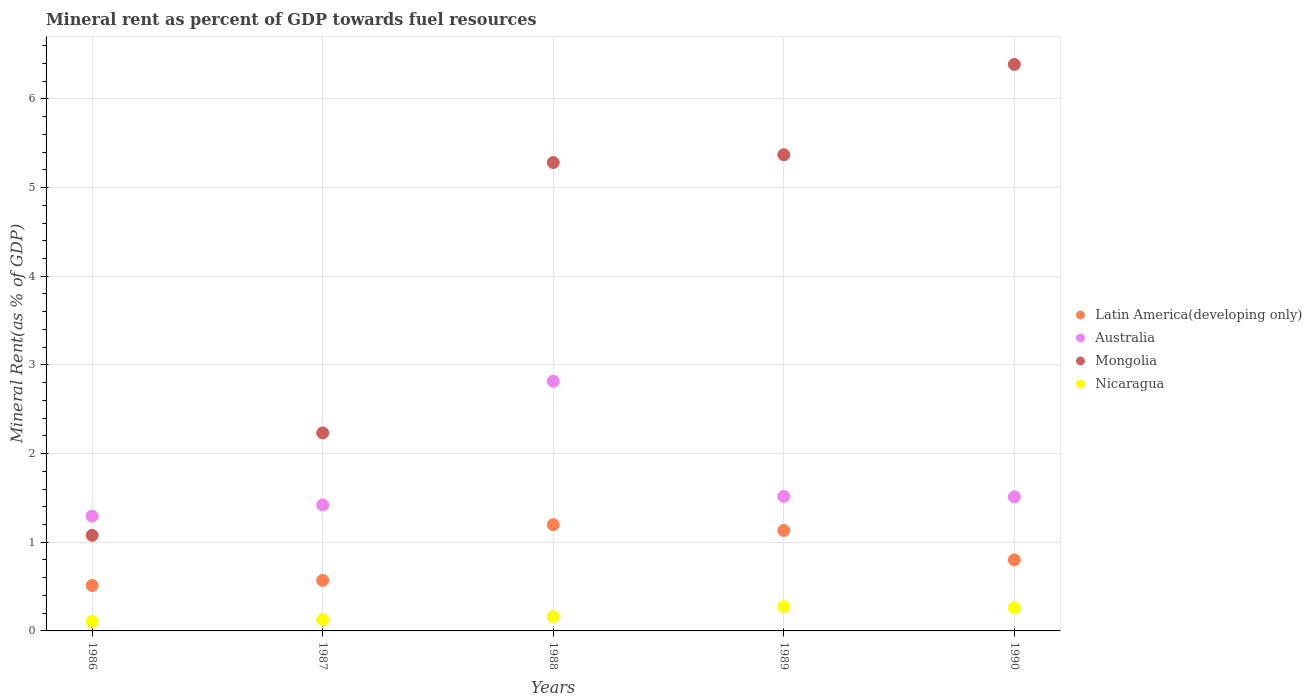What is the mineral rent in Mongolia in 1987?
Your response must be concise. 2.23. Across all years, what is the maximum mineral rent in Nicaragua?
Make the answer very short. 0.27. Across all years, what is the minimum mineral rent in Mongolia?
Keep it short and to the point. 1.08. In which year was the mineral rent in Nicaragua minimum?
Ensure brevity in your answer.  1986. What is the total mineral rent in Mongolia in the graph?
Your answer should be compact. 20.35. What is the difference between the mineral rent in Latin America(developing only) in 1986 and that in 1987?
Keep it short and to the point. -0.06. What is the difference between the mineral rent in Latin America(developing only) in 1990 and the mineral rent in Mongolia in 1987?
Offer a very short reply. -1.43. What is the average mineral rent in Nicaragua per year?
Keep it short and to the point. 0.19. In the year 1988, what is the difference between the mineral rent in Latin America(developing only) and mineral rent in Mongolia?
Offer a terse response. -4.08. What is the ratio of the mineral rent in Nicaragua in 1986 to that in 1987?
Provide a succinct answer. 0.83. Is the difference between the mineral rent in Latin America(developing only) in 1989 and 1990 greater than the difference between the mineral rent in Mongolia in 1989 and 1990?
Offer a very short reply. Yes. What is the difference between the highest and the second highest mineral rent in Mongolia?
Offer a very short reply. 1.02. What is the difference between the highest and the lowest mineral rent in Nicaragua?
Your response must be concise. 0.17. Does the mineral rent in Latin America(developing only) monotonically increase over the years?
Provide a short and direct response. No. How many dotlines are there?
Ensure brevity in your answer.  4. How many years are there in the graph?
Your response must be concise. 5. What is the difference between two consecutive major ticks on the Y-axis?
Your answer should be compact. 1. Does the graph contain grids?
Ensure brevity in your answer.  Yes. Where does the legend appear in the graph?
Ensure brevity in your answer.  Center right. What is the title of the graph?
Your response must be concise. Mineral rent as percent of GDP towards fuel resources. Does "Luxembourg" appear as one of the legend labels in the graph?
Your response must be concise. No. What is the label or title of the X-axis?
Your response must be concise. Years. What is the label or title of the Y-axis?
Your response must be concise. Mineral Rent(as % of GDP). What is the Mineral Rent(as % of GDP) of Latin America(developing only) in 1986?
Offer a very short reply. 0.51. What is the Mineral Rent(as % of GDP) in Australia in 1986?
Provide a succinct answer. 1.29. What is the Mineral Rent(as % of GDP) in Mongolia in 1986?
Your response must be concise. 1.08. What is the Mineral Rent(as % of GDP) of Nicaragua in 1986?
Your answer should be compact. 0.11. What is the Mineral Rent(as % of GDP) in Latin America(developing only) in 1987?
Make the answer very short. 0.57. What is the Mineral Rent(as % of GDP) of Australia in 1987?
Offer a very short reply. 1.42. What is the Mineral Rent(as % of GDP) of Mongolia in 1987?
Keep it short and to the point. 2.23. What is the Mineral Rent(as % of GDP) in Nicaragua in 1987?
Offer a very short reply. 0.13. What is the Mineral Rent(as % of GDP) of Latin America(developing only) in 1988?
Give a very brief answer. 1.2. What is the Mineral Rent(as % of GDP) of Australia in 1988?
Your answer should be very brief. 2.82. What is the Mineral Rent(as % of GDP) in Mongolia in 1988?
Provide a short and direct response. 5.28. What is the Mineral Rent(as % of GDP) of Nicaragua in 1988?
Give a very brief answer. 0.16. What is the Mineral Rent(as % of GDP) in Latin America(developing only) in 1989?
Provide a short and direct response. 1.13. What is the Mineral Rent(as % of GDP) of Australia in 1989?
Keep it short and to the point. 1.52. What is the Mineral Rent(as % of GDP) of Mongolia in 1989?
Your answer should be very brief. 5.37. What is the Mineral Rent(as % of GDP) of Nicaragua in 1989?
Ensure brevity in your answer.  0.27. What is the Mineral Rent(as % of GDP) in Latin America(developing only) in 1990?
Keep it short and to the point. 0.8. What is the Mineral Rent(as % of GDP) of Australia in 1990?
Offer a very short reply. 1.51. What is the Mineral Rent(as % of GDP) in Mongolia in 1990?
Offer a terse response. 6.39. What is the Mineral Rent(as % of GDP) of Nicaragua in 1990?
Offer a very short reply. 0.26. Across all years, what is the maximum Mineral Rent(as % of GDP) in Latin America(developing only)?
Your response must be concise. 1.2. Across all years, what is the maximum Mineral Rent(as % of GDP) in Australia?
Provide a short and direct response. 2.82. Across all years, what is the maximum Mineral Rent(as % of GDP) of Mongolia?
Your answer should be compact. 6.39. Across all years, what is the maximum Mineral Rent(as % of GDP) of Nicaragua?
Your response must be concise. 0.27. Across all years, what is the minimum Mineral Rent(as % of GDP) in Latin America(developing only)?
Your answer should be very brief. 0.51. Across all years, what is the minimum Mineral Rent(as % of GDP) in Australia?
Your response must be concise. 1.29. Across all years, what is the minimum Mineral Rent(as % of GDP) in Mongolia?
Make the answer very short. 1.08. Across all years, what is the minimum Mineral Rent(as % of GDP) of Nicaragua?
Give a very brief answer. 0.11. What is the total Mineral Rent(as % of GDP) of Latin America(developing only) in the graph?
Give a very brief answer. 4.21. What is the total Mineral Rent(as % of GDP) in Australia in the graph?
Offer a terse response. 8.56. What is the total Mineral Rent(as % of GDP) of Mongolia in the graph?
Your response must be concise. 20.35. What is the total Mineral Rent(as % of GDP) in Nicaragua in the graph?
Offer a terse response. 0.93. What is the difference between the Mineral Rent(as % of GDP) of Latin America(developing only) in 1986 and that in 1987?
Give a very brief answer. -0.06. What is the difference between the Mineral Rent(as % of GDP) of Australia in 1986 and that in 1987?
Your answer should be compact. -0.13. What is the difference between the Mineral Rent(as % of GDP) of Mongolia in 1986 and that in 1987?
Offer a terse response. -1.16. What is the difference between the Mineral Rent(as % of GDP) of Nicaragua in 1986 and that in 1987?
Give a very brief answer. -0.02. What is the difference between the Mineral Rent(as % of GDP) of Latin America(developing only) in 1986 and that in 1988?
Keep it short and to the point. -0.69. What is the difference between the Mineral Rent(as % of GDP) of Australia in 1986 and that in 1988?
Your answer should be compact. -1.52. What is the difference between the Mineral Rent(as % of GDP) of Mongolia in 1986 and that in 1988?
Offer a very short reply. -4.2. What is the difference between the Mineral Rent(as % of GDP) in Nicaragua in 1986 and that in 1988?
Make the answer very short. -0.06. What is the difference between the Mineral Rent(as % of GDP) in Latin America(developing only) in 1986 and that in 1989?
Your response must be concise. -0.62. What is the difference between the Mineral Rent(as % of GDP) of Australia in 1986 and that in 1989?
Your answer should be very brief. -0.22. What is the difference between the Mineral Rent(as % of GDP) in Mongolia in 1986 and that in 1989?
Ensure brevity in your answer.  -4.29. What is the difference between the Mineral Rent(as % of GDP) in Nicaragua in 1986 and that in 1989?
Give a very brief answer. -0.17. What is the difference between the Mineral Rent(as % of GDP) of Latin America(developing only) in 1986 and that in 1990?
Offer a very short reply. -0.29. What is the difference between the Mineral Rent(as % of GDP) in Australia in 1986 and that in 1990?
Make the answer very short. -0.22. What is the difference between the Mineral Rent(as % of GDP) of Mongolia in 1986 and that in 1990?
Your answer should be compact. -5.31. What is the difference between the Mineral Rent(as % of GDP) of Nicaragua in 1986 and that in 1990?
Your answer should be very brief. -0.16. What is the difference between the Mineral Rent(as % of GDP) of Latin America(developing only) in 1987 and that in 1988?
Provide a short and direct response. -0.63. What is the difference between the Mineral Rent(as % of GDP) in Australia in 1987 and that in 1988?
Provide a short and direct response. -1.4. What is the difference between the Mineral Rent(as % of GDP) of Mongolia in 1987 and that in 1988?
Make the answer very short. -3.05. What is the difference between the Mineral Rent(as % of GDP) of Nicaragua in 1987 and that in 1988?
Your answer should be very brief. -0.03. What is the difference between the Mineral Rent(as % of GDP) of Latin America(developing only) in 1987 and that in 1989?
Your response must be concise. -0.56. What is the difference between the Mineral Rent(as % of GDP) in Australia in 1987 and that in 1989?
Give a very brief answer. -0.1. What is the difference between the Mineral Rent(as % of GDP) of Mongolia in 1987 and that in 1989?
Offer a terse response. -3.14. What is the difference between the Mineral Rent(as % of GDP) of Nicaragua in 1987 and that in 1989?
Offer a very short reply. -0.15. What is the difference between the Mineral Rent(as % of GDP) of Latin America(developing only) in 1987 and that in 1990?
Offer a very short reply. -0.23. What is the difference between the Mineral Rent(as % of GDP) in Australia in 1987 and that in 1990?
Provide a short and direct response. -0.09. What is the difference between the Mineral Rent(as % of GDP) in Mongolia in 1987 and that in 1990?
Ensure brevity in your answer.  -4.16. What is the difference between the Mineral Rent(as % of GDP) of Nicaragua in 1987 and that in 1990?
Your response must be concise. -0.14. What is the difference between the Mineral Rent(as % of GDP) in Latin America(developing only) in 1988 and that in 1989?
Your answer should be compact. 0.07. What is the difference between the Mineral Rent(as % of GDP) in Australia in 1988 and that in 1989?
Offer a terse response. 1.3. What is the difference between the Mineral Rent(as % of GDP) of Mongolia in 1988 and that in 1989?
Offer a terse response. -0.09. What is the difference between the Mineral Rent(as % of GDP) of Nicaragua in 1988 and that in 1989?
Offer a very short reply. -0.11. What is the difference between the Mineral Rent(as % of GDP) in Latin America(developing only) in 1988 and that in 1990?
Your answer should be compact. 0.4. What is the difference between the Mineral Rent(as % of GDP) of Australia in 1988 and that in 1990?
Ensure brevity in your answer.  1.3. What is the difference between the Mineral Rent(as % of GDP) of Mongolia in 1988 and that in 1990?
Offer a terse response. -1.11. What is the difference between the Mineral Rent(as % of GDP) of Nicaragua in 1988 and that in 1990?
Your answer should be very brief. -0.1. What is the difference between the Mineral Rent(as % of GDP) of Latin America(developing only) in 1989 and that in 1990?
Offer a terse response. 0.33. What is the difference between the Mineral Rent(as % of GDP) of Australia in 1989 and that in 1990?
Your answer should be compact. 0. What is the difference between the Mineral Rent(as % of GDP) in Mongolia in 1989 and that in 1990?
Your response must be concise. -1.02. What is the difference between the Mineral Rent(as % of GDP) of Nicaragua in 1989 and that in 1990?
Your response must be concise. 0.01. What is the difference between the Mineral Rent(as % of GDP) of Latin America(developing only) in 1986 and the Mineral Rent(as % of GDP) of Australia in 1987?
Offer a terse response. -0.91. What is the difference between the Mineral Rent(as % of GDP) in Latin America(developing only) in 1986 and the Mineral Rent(as % of GDP) in Mongolia in 1987?
Give a very brief answer. -1.72. What is the difference between the Mineral Rent(as % of GDP) of Latin America(developing only) in 1986 and the Mineral Rent(as % of GDP) of Nicaragua in 1987?
Provide a short and direct response. 0.39. What is the difference between the Mineral Rent(as % of GDP) of Australia in 1986 and the Mineral Rent(as % of GDP) of Mongolia in 1987?
Your answer should be very brief. -0.94. What is the difference between the Mineral Rent(as % of GDP) of Australia in 1986 and the Mineral Rent(as % of GDP) of Nicaragua in 1987?
Ensure brevity in your answer.  1.17. What is the difference between the Mineral Rent(as % of GDP) of Mongolia in 1986 and the Mineral Rent(as % of GDP) of Nicaragua in 1987?
Keep it short and to the point. 0.95. What is the difference between the Mineral Rent(as % of GDP) in Latin America(developing only) in 1986 and the Mineral Rent(as % of GDP) in Australia in 1988?
Offer a very short reply. -2.3. What is the difference between the Mineral Rent(as % of GDP) of Latin America(developing only) in 1986 and the Mineral Rent(as % of GDP) of Mongolia in 1988?
Your answer should be compact. -4.77. What is the difference between the Mineral Rent(as % of GDP) in Latin America(developing only) in 1986 and the Mineral Rent(as % of GDP) in Nicaragua in 1988?
Provide a succinct answer. 0.35. What is the difference between the Mineral Rent(as % of GDP) of Australia in 1986 and the Mineral Rent(as % of GDP) of Mongolia in 1988?
Keep it short and to the point. -3.99. What is the difference between the Mineral Rent(as % of GDP) in Australia in 1986 and the Mineral Rent(as % of GDP) in Nicaragua in 1988?
Give a very brief answer. 1.13. What is the difference between the Mineral Rent(as % of GDP) in Mongolia in 1986 and the Mineral Rent(as % of GDP) in Nicaragua in 1988?
Keep it short and to the point. 0.92. What is the difference between the Mineral Rent(as % of GDP) in Latin America(developing only) in 1986 and the Mineral Rent(as % of GDP) in Australia in 1989?
Keep it short and to the point. -1. What is the difference between the Mineral Rent(as % of GDP) of Latin America(developing only) in 1986 and the Mineral Rent(as % of GDP) of Mongolia in 1989?
Provide a short and direct response. -4.86. What is the difference between the Mineral Rent(as % of GDP) in Latin America(developing only) in 1986 and the Mineral Rent(as % of GDP) in Nicaragua in 1989?
Keep it short and to the point. 0.24. What is the difference between the Mineral Rent(as % of GDP) of Australia in 1986 and the Mineral Rent(as % of GDP) of Mongolia in 1989?
Your response must be concise. -4.08. What is the difference between the Mineral Rent(as % of GDP) of Australia in 1986 and the Mineral Rent(as % of GDP) of Nicaragua in 1989?
Your answer should be compact. 1.02. What is the difference between the Mineral Rent(as % of GDP) of Mongolia in 1986 and the Mineral Rent(as % of GDP) of Nicaragua in 1989?
Give a very brief answer. 0.81. What is the difference between the Mineral Rent(as % of GDP) of Latin America(developing only) in 1986 and the Mineral Rent(as % of GDP) of Australia in 1990?
Provide a short and direct response. -1. What is the difference between the Mineral Rent(as % of GDP) in Latin America(developing only) in 1986 and the Mineral Rent(as % of GDP) in Mongolia in 1990?
Your answer should be very brief. -5.88. What is the difference between the Mineral Rent(as % of GDP) in Latin America(developing only) in 1986 and the Mineral Rent(as % of GDP) in Nicaragua in 1990?
Keep it short and to the point. 0.25. What is the difference between the Mineral Rent(as % of GDP) of Australia in 1986 and the Mineral Rent(as % of GDP) of Mongolia in 1990?
Your answer should be compact. -5.09. What is the difference between the Mineral Rent(as % of GDP) in Australia in 1986 and the Mineral Rent(as % of GDP) in Nicaragua in 1990?
Provide a succinct answer. 1.03. What is the difference between the Mineral Rent(as % of GDP) of Mongolia in 1986 and the Mineral Rent(as % of GDP) of Nicaragua in 1990?
Provide a short and direct response. 0.82. What is the difference between the Mineral Rent(as % of GDP) of Latin America(developing only) in 1987 and the Mineral Rent(as % of GDP) of Australia in 1988?
Give a very brief answer. -2.25. What is the difference between the Mineral Rent(as % of GDP) in Latin America(developing only) in 1987 and the Mineral Rent(as % of GDP) in Mongolia in 1988?
Offer a very short reply. -4.71. What is the difference between the Mineral Rent(as % of GDP) of Latin America(developing only) in 1987 and the Mineral Rent(as % of GDP) of Nicaragua in 1988?
Offer a terse response. 0.41. What is the difference between the Mineral Rent(as % of GDP) of Australia in 1987 and the Mineral Rent(as % of GDP) of Mongolia in 1988?
Keep it short and to the point. -3.86. What is the difference between the Mineral Rent(as % of GDP) in Australia in 1987 and the Mineral Rent(as % of GDP) in Nicaragua in 1988?
Offer a terse response. 1.26. What is the difference between the Mineral Rent(as % of GDP) of Mongolia in 1987 and the Mineral Rent(as % of GDP) of Nicaragua in 1988?
Your response must be concise. 2.07. What is the difference between the Mineral Rent(as % of GDP) in Latin America(developing only) in 1987 and the Mineral Rent(as % of GDP) in Australia in 1989?
Ensure brevity in your answer.  -0.95. What is the difference between the Mineral Rent(as % of GDP) of Latin America(developing only) in 1987 and the Mineral Rent(as % of GDP) of Mongolia in 1989?
Provide a succinct answer. -4.8. What is the difference between the Mineral Rent(as % of GDP) in Latin America(developing only) in 1987 and the Mineral Rent(as % of GDP) in Nicaragua in 1989?
Your response must be concise. 0.3. What is the difference between the Mineral Rent(as % of GDP) in Australia in 1987 and the Mineral Rent(as % of GDP) in Mongolia in 1989?
Your answer should be very brief. -3.95. What is the difference between the Mineral Rent(as % of GDP) of Australia in 1987 and the Mineral Rent(as % of GDP) of Nicaragua in 1989?
Your answer should be very brief. 1.15. What is the difference between the Mineral Rent(as % of GDP) of Mongolia in 1987 and the Mineral Rent(as % of GDP) of Nicaragua in 1989?
Give a very brief answer. 1.96. What is the difference between the Mineral Rent(as % of GDP) in Latin America(developing only) in 1987 and the Mineral Rent(as % of GDP) in Australia in 1990?
Keep it short and to the point. -0.94. What is the difference between the Mineral Rent(as % of GDP) in Latin America(developing only) in 1987 and the Mineral Rent(as % of GDP) in Mongolia in 1990?
Make the answer very short. -5.82. What is the difference between the Mineral Rent(as % of GDP) of Latin America(developing only) in 1987 and the Mineral Rent(as % of GDP) of Nicaragua in 1990?
Keep it short and to the point. 0.31. What is the difference between the Mineral Rent(as % of GDP) of Australia in 1987 and the Mineral Rent(as % of GDP) of Mongolia in 1990?
Your answer should be very brief. -4.97. What is the difference between the Mineral Rent(as % of GDP) in Australia in 1987 and the Mineral Rent(as % of GDP) in Nicaragua in 1990?
Your answer should be very brief. 1.16. What is the difference between the Mineral Rent(as % of GDP) in Mongolia in 1987 and the Mineral Rent(as % of GDP) in Nicaragua in 1990?
Your answer should be very brief. 1.97. What is the difference between the Mineral Rent(as % of GDP) of Latin America(developing only) in 1988 and the Mineral Rent(as % of GDP) of Australia in 1989?
Keep it short and to the point. -0.32. What is the difference between the Mineral Rent(as % of GDP) in Latin America(developing only) in 1988 and the Mineral Rent(as % of GDP) in Mongolia in 1989?
Offer a very short reply. -4.17. What is the difference between the Mineral Rent(as % of GDP) in Latin America(developing only) in 1988 and the Mineral Rent(as % of GDP) in Nicaragua in 1989?
Offer a very short reply. 0.93. What is the difference between the Mineral Rent(as % of GDP) in Australia in 1988 and the Mineral Rent(as % of GDP) in Mongolia in 1989?
Provide a succinct answer. -2.55. What is the difference between the Mineral Rent(as % of GDP) of Australia in 1988 and the Mineral Rent(as % of GDP) of Nicaragua in 1989?
Ensure brevity in your answer.  2.54. What is the difference between the Mineral Rent(as % of GDP) of Mongolia in 1988 and the Mineral Rent(as % of GDP) of Nicaragua in 1989?
Keep it short and to the point. 5.01. What is the difference between the Mineral Rent(as % of GDP) in Latin America(developing only) in 1988 and the Mineral Rent(as % of GDP) in Australia in 1990?
Make the answer very short. -0.31. What is the difference between the Mineral Rent(as % of GDP) of Latin America(developing only) in 1988 and the Mineral Rent(as % of GDP) of Mongolia in 1990?
Give a very brief answer. -5.19. What is the difference between the Mineral Rent(as % of GDP) in Latin America(developing only) in 1988 and the Mineral Rent(as % of GDP) in Nicaragua in 1990?
Provide a short and direct response. 0.94. What is the difference between the Mineral Rent(as % of GDP) in Australia in 1988 and the Mineral Rent(as % of GDP) in Mongolia in 1990?
Make the answer very short. -3.57. What is the difference between the Mineral Rent(as % of GDP) in Australia in 1988 and the Mineral Rent(as % of GDP) in Nicaragua in 1990?
Your answer should be very brief. 2.55. What is the difference between the Mineral Rent(as % of GDP) of Mongolia in 1988 and the Mineral Rent(as % of GDP) of Nicaragua in 1990?
Give a very brief answer. 5.02. What is the difference between the Mineral Rent(as % of GDP) of Latin America(developing only) in 1989 and the Mineral Rent(as % of GDP) of Australia in 1990?
Make the answer very short. -0.38. What is the difference between the Mineral Rent(as % of GDP) in Latin America(developing only) in 1989 and the Mineral Rent(as % of GDP) in Mongolia in 1990?
Your response must be concise. -5.26. What is the difference between the Mineral Rent(as % of GDP) of Latin America(developing only) in 1989 and the Mineral Rent(as % of GDP) of Nicaragua in 1990?
Offer a terse response. 0.87. What is the difference between the Mineral Rent(as % of GDP) in Australia in 1989 and the Mineral Rent(as % of GDP) in Mongolia in 1990?
Provide a succinct answer. -4.87. What is the difference between the Mineral Rent(as % of GDP) in Australia in 1989 and the Mineral Rent(as % of GDP) in Nicaragua in 1990?
Keep it short and to the point. 1.25. What is the difference between the Mineral Rent(as % of GDP) in Mongolia in 1989 and the Mineral Rent(as % of GDP) in Nicaragua in 1990?
Give a very brief answer. 5.11. What is the average Mineral Rent(as % of GDP) of Latin America(developing only) per year?
Offer a very short reply. 0.84. What is the average Mineral Rent(as % of GDP) of Australia per year?
Offer a terse response. 1.71. What is the average Mineral Rent(as % of GDP) in Mongolia per year?
Your answer should be compact. 4.07. What is the average Mineral Rent(as % of GDP) in Nicaragua per year?
Ensure brevity in your answer.  0.19. In the year 1986, what is the difference between the Mineral Rent(as % of GDP) in Latin America(developing only) and Mineral Rent(as % of GDP) in Australia?
Ensure brevity in your answer.  -0.78. In the year 1986, what is the difference between the Mineral Rent(as % of GDP) of Latin America(developing only) and Mineral Rent(as % of GDP) of Mongolia?
Your response must be concise. -0.57. In the year 1986, what is the difference between the Mineral Rent(as % of GDP) in Latin America(developing only) and Mineral Rent(as % of GDP) in Nicaragua?
Your answer should be very brief. 0.41. In the year 1986, what is the difference between the Mineral Rent(as % of GDP) of Australia and Mineral Rent(as % of GDP) of Mongolia?
Give a very brief answer. 0.22. In the year 1986, what is the difference between the Mineral Rent(as % of GDP) in Australia and Mineral Rent(as % of GDP) in Nicaragua?
Provide a succinct answer. 1.19. In the year 1986, what is the difference between the Mineral Rent(as % of GDP) of Mongolia and Mineral Rent(as % of GDP) of Nicaragua?
Offer a very short reply. 0.97. In the year 1987, what is the difference between the Mineral Rent(as % of GDP) of Latin America(developing only) and Mineral Rent(as % of GDP) of Australia?
Your response must be concise. -0.85. In the year 1987, what is the difference between the Mineral Rent(as % of GDP) in Latin America(developing only) and Mineral Rent(as % of GDP) in Mongolia?
Keep it short and to the point. -1.66. In the year 1987, what is the difference between the Mineral Rent(as % of GDP) of Latin America(developing only) and Mineral Rent(as % of GDP) of Nicaragua?
Offer a very short reply. 0.44. In the year 1987, what is the difference between the Mineral Rent(as % of GDP) of Australia and Mineral Rent(as % of GDP) of Mongolia?
Your answer should be very brief. -0.81. In the year 1987, what is the difference between the Mineral Rent(as % of GDP) of Australia and Mineral Rent(as % of GDP) of Nicaragua?
Make the answer very short. 1.29. In the year 1987, what is the difference between the Mineral Rent(as % of GDP) of Mongolia and Mineral Rent(as % of GDP) of Nicaragua?
Make the answer very short. 2.11. In the year 1988, what is the difference between the Mineral Rent(as % of GDP) of Latin America(developing only) and Mineral Rent(as % of GDP) of Australia?
Provide a short and direct response. -1.62. In the year 1988, what is the difference between the Mineral Rent(as % of GDP) of Latin America(developing only) and Mineral Rent(as % of GDP) of Mongolia?
Offer a terse response. -4.08. In the year 1988, what is the difference between the Mineral Rent(as % of GDP) in Latin America(developing only) and Mineral Rent(as % of GDP) in Nicaragua?
Offer a very short reply. 1.04. In the year 1988, what is the difference between the Mineral Rent(as % of GDP) in Australia and Mineral Rent(as % of GDP) in Mongolia?
Offer a very short reply. -2.47. In the year 1988, what is the difference between the Mineral Rent(as % of GDP) in Australia and Mineral Rent(as % of GDP) in Nicaragua?
Your answer should be compact. 2.65. In the year 1988, what is the difference between the Mineral Rent(as % of GDP) in Mongolia and Mineral Rent(as % of GDP) in Nicaragua?
Your response must be concise. 5.12. In the year 1989, what is the difference between the Mineral Rent(as % of GDP) in Latin America(developing only) and Mineral Rent(as % of GDP) in Australia?
Your answer should be compact. -0.38. In the year 1989, what is the difference between the Mineral Rent(as % of GDP) in Latin America(developing only) and Mineral Rent(as % of GDP) in Mongolia?
Make the answer very short. -4.24. In the year 1989, what is the difference between the Mineral Rent(as % of GDP) of Latin America(developing only) and Mineral Rent(as % of GDP) of Nicaragua?
Offer a very short reply. 0.86. In the year 1989, what is the difference between the Mineral Rent(as % of GDP) of Australia and Mineral Rent(as % of GDP) of Mongolia?
Your answer should be very brief. -3.85. In the year 1989, what is the difference between the Mineral Rent(as % of GDP) of Australia and Mineral Rent(as % of GDP) of Nicaragua?
Keep it short and to the point. 1.24. In the year 1989, what is the difference between the Mineral Rent(as % of GDP) of Mongolia and Mineral Rent(as % of GDP) of Nicaragua?
Your answer should be compact. 5.1. In the year 1990, what is the difference between the Mineral Rent(as % of GDP) in Latin America(developing only) and Mineral Rent(as % of GDP) in Australia?
Your answer should be very brief. -0.71. In the year 1990, what is the difference between the Mineral Rent(as % of GDP) in Latin America(developing only) and Mineral Rent(as % of GDP) in Mongolia?
Offer a terse response. -5.59. In the year 1990, what is the difference between the Mineral Rent(as % of GDP) of Latin America(developing only) and Mineral Rent(as % of GDP) of Nicaragua?
Your response must be concise. 0.54. In the year 1990, what is the difference between the Mineral Rent(as % of GDP) of Australia and Mineral Rent(as % of GDP) of Mongolia?
Keep it short and to the point. -4.88. In the year 1990, what is the difference between the Mineral Rent(as % of GDP) of Australia and Mineral Rent(as % of GDP) of Nicaragua?
Your answer should be very brief. 1.25. In the year 1990, what is the difference between the Mineral Rent(as % of GDP) of Mongolia and Mineral Rent(as % of GDP) of Nicaragua?
Offer a terse response. 6.13. What is the ratio of the Mineral Rent(as % of GDP) in Latin America(developing only) in 1986 to that in 1987?
Make the answer very short. 0.9. What is the ratio of the Mineral Rent(as % of GDP) of Australia in 1986 to that in 1987?
Your response must be concise. 0.91. What is the ratio of the Mineral Rent(as % of GDP) of Mongolia in 1986 to that in 1987?
Offer a very short reply. 0.48. What is the ratio of the Mineral Rent(as % of GDP) of Nicaragua in 1986 to that in 1987?
Give a very brief answer. 0.83. What is the ratio of the Mineral Rent(as % of GDP) of Latin America(developing only) in 1986 to that in 1988?
Ensure brevity in your answer.  0.43. What is the ratio of the Mineral Rent(as % of GDP) in Australia in 1986 to that in 1988?
Make the answer very short. 0.46. What is the ratio of the Mineral Rent(as % of GDP) in Mongolia in 1986 to that in 1988?
Make the answer very short. 0.2. What is the ratio of the Mineral Rent(as % of GDP) in Nicaragua in 1986 to that in 1988?
Your answer should be compact. 0.65. What is the ratio of the Mineral Rent(as % of GDP) of Latin America(developing only) in 1986 to that in 1989?
Ensure brevity in your answer.  0.45. What is the ratio of the Mineral Rent(as % of GDP) of Australia in 1986 to that in 1989?
Offer a very short reply. 0.85. What is the ratio of the Mineral Rent(as % of GDP) in Mongolia in 1986 to that in 1989?
Provide a short and direct response. 0.2. What is the ratio of the Mineral Rent(as % of GDP) in Nicaragua in 1986 to that in 1989?
Your answer should be compact. 0.39. What is the ratio of the Mineral Rent(as % of GDP) in Latin America(developing only) in 1986 to that in 1990?
Your response must be concise. 0.64. What is the ratio of the Mineral Rent(as % of GDP) of Australia in 1986 to that in 1990?
Keep it short and to the point. 0.86. What is the ratio of the Mineral Rent(as % of GDP) of Mongolia in 1986 to that in 1990?
Make the answer very short. 0.17. What is the ratio of the Mineral Rent(as % of GDP) in Nicaragua in 1986 to that in 1990?
Provide a short and direct response. 0.4. What is the ratio of the Mineral Rent(as % of GDP) in Latin America(developing only) in 1987 to that in 1988?
Your answer should be compact. 0.48. What is the ratio of the Mineral Rent(as % of GDP) in Australia in 1987 to that in 1988?
Provide a succinct answer. 0.5. What is the ratio of the Mineral Rent(as % of GDP) of Mongolia in 1987 to that in 1988?
Provide a short and direct response. 0.42. What is the ratio of the Mineral Rent(as % of GDP) of Nicaragua in 1987 to that in 1988?
Offer a very short reply. 0.79. What is the ratio of the Mineral Rent(as % of GDP) in Latin America(developing only) in 1987 to that in 1989?
Ensure brevity in your answer.  0.5. What is the ratio of the Mineral Rent(as % of GDP) of Australia in 1987 to that in 1989?
Give a very brief answer. 0.94. What is the ratio of the Mineral Rent(as % of GDP) of Mongolia in 1987 to that in 1989?
Your answer should be very brief. 0.42. What is the ratio of the Mineral Rent(as % of GDP) of Nicaragua in 1987 to that in 1989?
Keep it short and to the point. 0.46. What is the ratio of the Mineral Rent(as % of GDP) in Latin America(developing only) in 1987 to that in 1990?
Your answer should be compact. 0.71. What is the ratio of the Mineral Rent(as % of GDP) in Australia in 1987 to that in 1990?
Ensure brevity in your answer.  0.94. What is the ratio of the Mineral Rent(as % of GDP) in Mongolia in 1987 to that in 1990?
Make the answer very short. 0.35. What is the ratio of the Mineral Rent(as % of GDP) of Nicaragua in 1987 to that in 1990?
Give a very brief answer. 0.48. What is the ratio of the Mineral Rent(as % of GDP) of Latin America(developing only) in 1988 to that in 1989?
Ensure brevity in your answer.  1.06. What is the ratio of the Mineral Rent(as % of GDP) of Australia in 1988 to that in 1989?
Give a very brief answer. 1.86. What is the ratio of the Mineral Rent(as % of GDP) of Mongolia in 1988 to that in 1989?
Offer a terse response. 0.98. What is the ratio of the Mineral Rent(as % of GDP) of Nicaragua in 1988 to that in 1989?
Ensure brevity in your answer.  0.59. What is the ratio of the Mineral Rent(as % of GDP) in Latin America(developing only) in 1988 to that in 1990?
Your answer should be compact. 1.49. What is the ratio of the Mineral Rent(as % of GDP) of Australia in 1988 to that in 1990?
Make the answer very short. 1.86. What is the ratio of the Mineral Rent(as % of GDP) of Mongolia in 1988 to that in 1990?
Provide a succinct answer. 0.83. What is the ratio of the Mineral Rent(as % of GDP) of Nicaragua in 1988 to that in 1990?
Offer a very short reply. 0.62. What is the ratio of the Mineral Rent(as % of GDP) of Latin America(developing only) in 1989 to that in 1990?
Your answer should be very brief. 1.41. What is the ratio of the Mineral Rent(as % of GDP) in Australia in 1989 to that in 1990?
Provide a short and direct response. 1. What is the ratio of the Mineral Rent(as % of GDP) in Mongolia in 1989 to that in 1990?
Your response must be concise. 0.84. What is the ratio of the Mineral Rent(as % of GDP) of Nicaragua in 1989 to that in 1990?
Your answer should be very brief. 1.04. What is the difference between the highest and the second highest Mineral Rent(as % of GDP) in Latin America(developing only)?
Keep it short and to the point. 0.07. What is the difference between the highest and the second highest Mineral Rent(as % of GDP) of Australia?
Keep it short and to the point. 1.3. What is the difference between the highest and the second highest Mineral Rent(as % of GDP) of Mongolia?
Ensure brevity in your answer.  1.02. What is the difference between the highest and the second highest Mineral Rent(as % of GDP) in Nicaragua?
Your answer should be very brief. 0.01. What is the difference between the highest and the lowest Mineral Rent(as % of GDP) of Latin America(developing only)?
Your response must be concise. 0.69. What is the difference between the highest and the lowest Mineral Rent(as % of GDP) in Australia?
Your response must be concise. 1.52. What is the difference between the highest and the lowest Mineral Rent(as % of GDP) of Mongolia?
Make the answer very short. 5.31. What is the difference between the highest and the lowest Mineral Rent(as % of GDP) in Nicaragua?
Your answer should be compact. 0.17. 